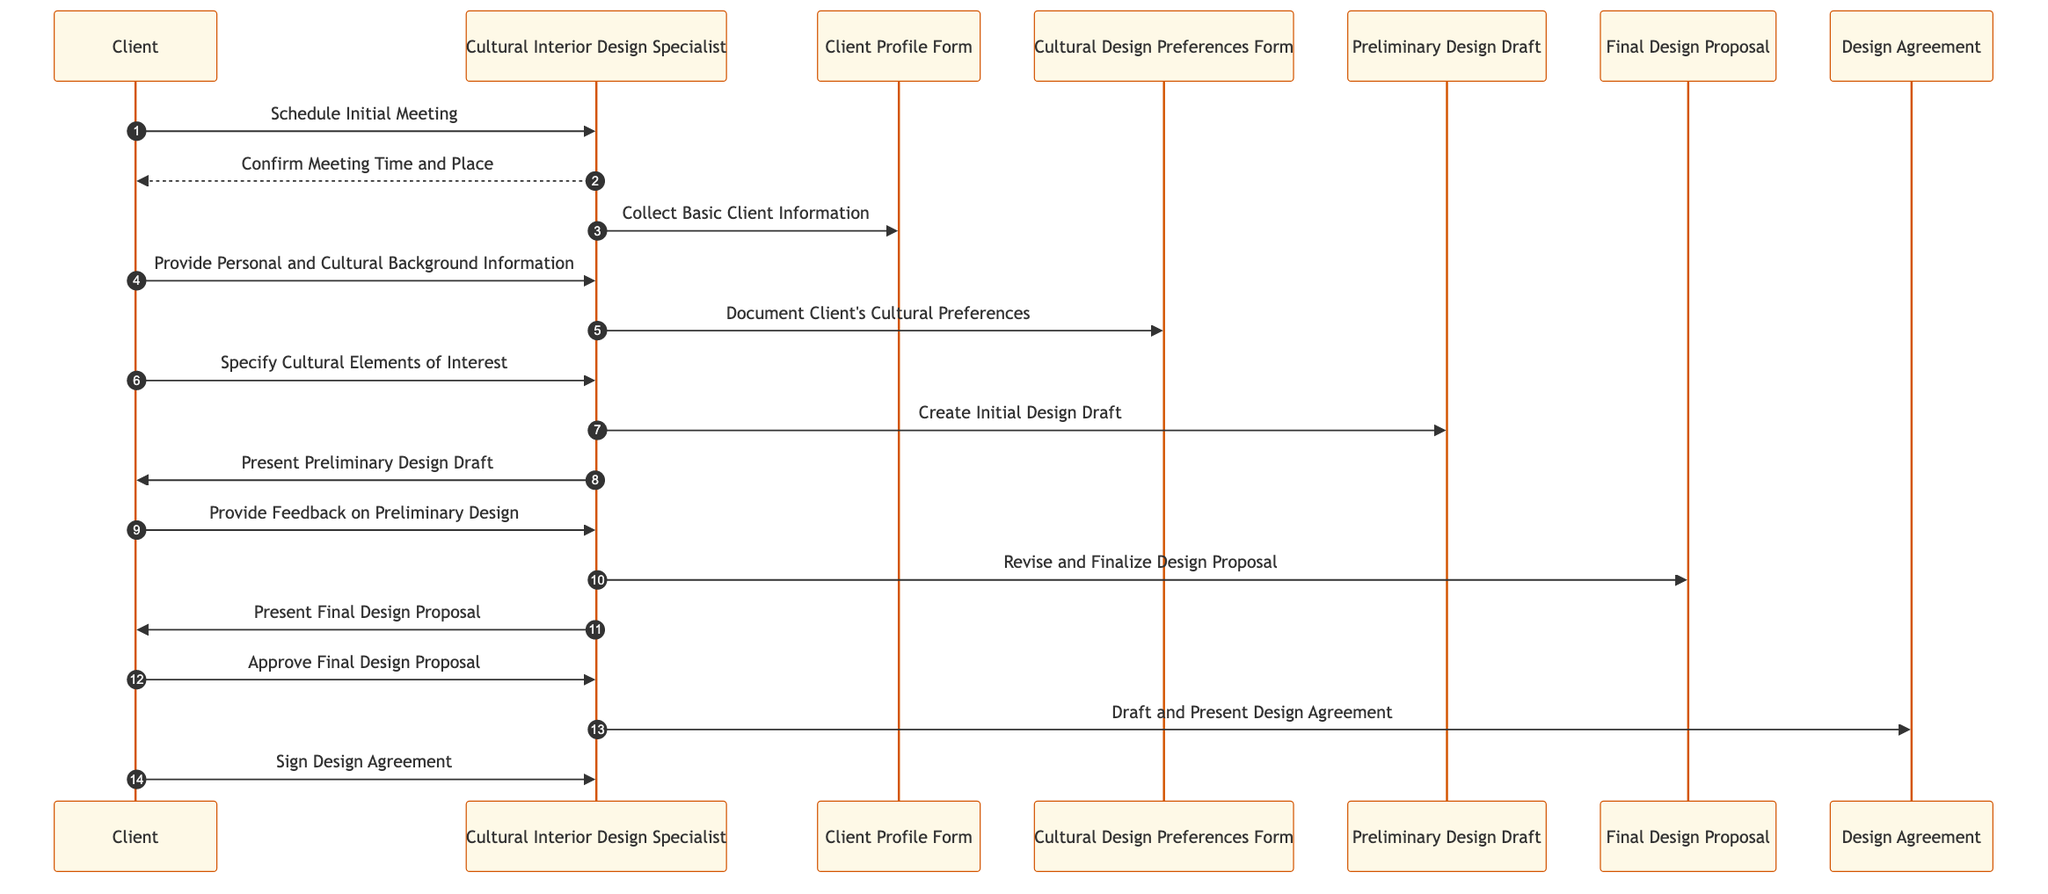What is the first action in the sequence? The first action in the sequence is "Schedule Initial Meeting" from the Client to the Cultural Interior Design Specialist. This can be determined by examining the first message sent in the diagram.
Answer: Schedule Initial Meeting How many actors are present in the diagram? The diagram includes two actors: the Client and the Cultural Interior Design Specialist. This can be identified by counting the participants listed in the sequence diagram.
Answer: 2 What is the last action in the sequence? The last action in the sequence is "Sign Design Agreement" from the Client to the Cultural Interior Design Specialist. This is evident from the final message at the end of the flow.
Answer: Sign Design Agreement Which document does the Specialist create after gathering the client's cultural preferences? After documenting the client's cultural preferences, the Specialist creates the Preliminary Design Draft. This can be traced by following the flow of messages concerning the design process.
Answer: Preliminary Design Draft What is the message the Client sends to the Specialist after receiving the Preliminary Design Draft? The Client sends the message "Provide Feedback on Preliminary Design" after receiving the Preliminary Design Draft. This is indicated in the sequence where the Client responds to the Specialist's previous action.
Answer: Provide Feedback on Preliminary Design How many design-related documents are generated in the sequence? Three design-related documents are generated in the sequence: Preliminary Design Draft, Final Design Proposal, and Design Agreement. This can be determined by identifying the key design documents mentioned throughout the interactions.
Answer: 3 What does the Cultural Interior Design Specialist do after the Client approves the Final Design Proposal? After the Client approves the Final Design Proposal, the Specialist drafts and presents the Design Agreement. This can be followed by checking the sequence of messages that come after client approval.
Answer: Draft and Present Design Agreement What specific cultural elements does the Client specify? The Client specifies cultural elements of interest such as "Japanese Tea Ceremony" and "Moroccan Tiling". These examples are provided by the Client during their interaction with the Specialist.
Answer: Japanese Tea Ceremony, Moroccan Tiling What type of agreement is presented at the end of the sequence? The type of agreement presented at the end of the sequence is the Design Agreement. This can be identified as the final document mentioned in the interactions of the diagram.
Answer: Design Agreement 